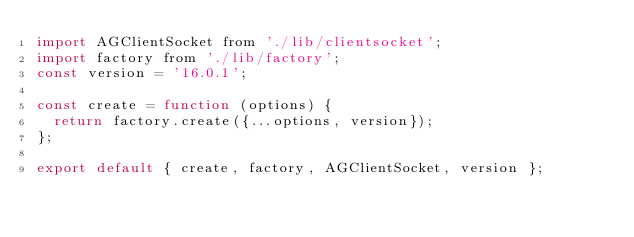Convert code to text. <code><loc_0><loc_0><loc_500><loc_500><_JavaScript_>import AGClientSocket from './lib/clientsocket';
import factory from './lib/factory';
const version = '16.0.1';

const create = function (options) {
  return factory.create({...options, version});
};

export default { create, factory, AGClientSocket, version };
</code> 